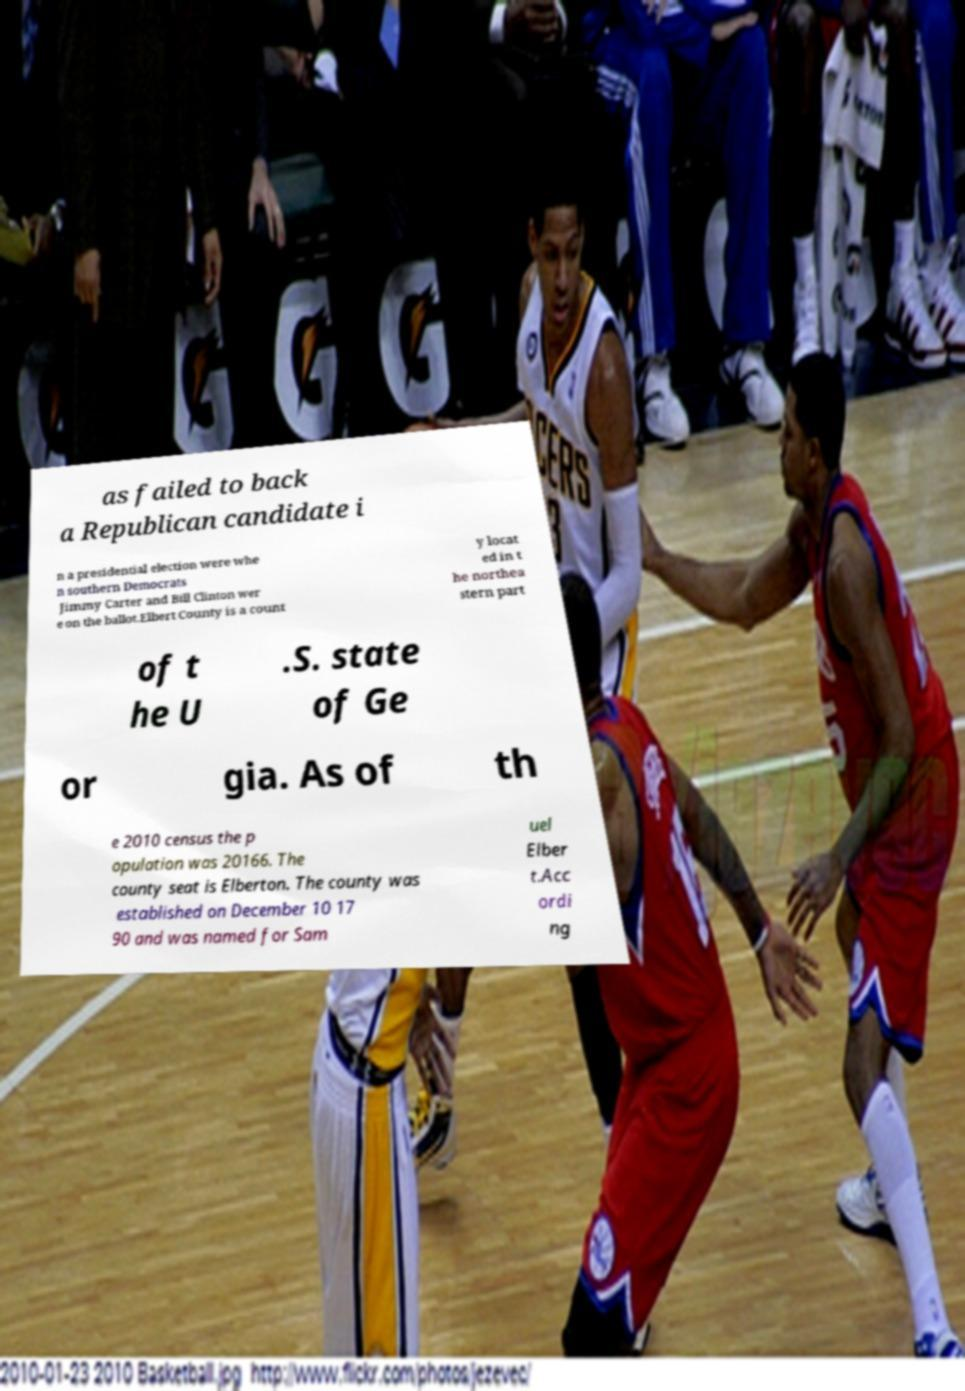What messages or text are displayed in this image? I need them in a readable, typed format. as failed to back a Republican candidate i n a presidential election were whe n southern Democrats Jimmy Carter and Bill Clinton wer e on the ballot.Elbert County is a count y locat ed in t he northea stern part of t he U .S. state of Ge or gia. As of th e 2010 census the p opulation was 20166. The county seat is Elberton. The county was established on December 10 17 90 and was named for Sam uel Elber t.Acc ordi ng 